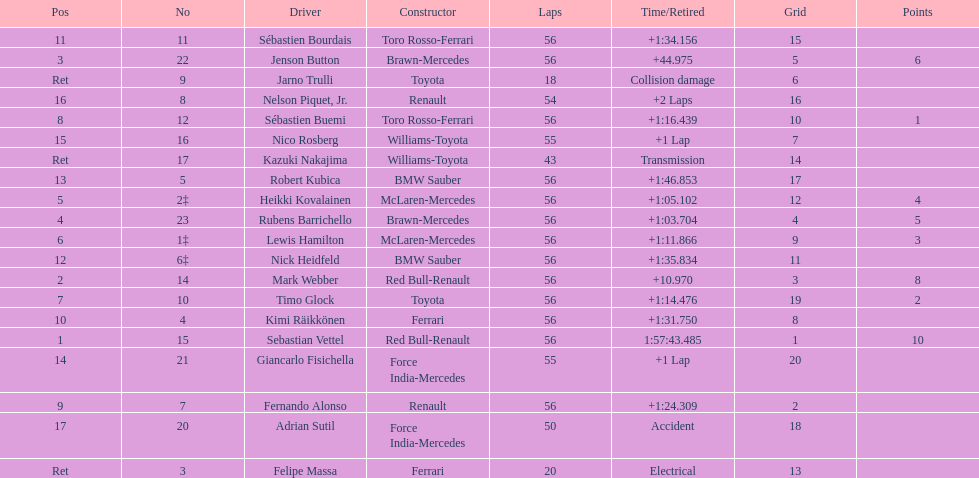Which driver is the only driver who retired because of collision damage? Jarno Trulli. 